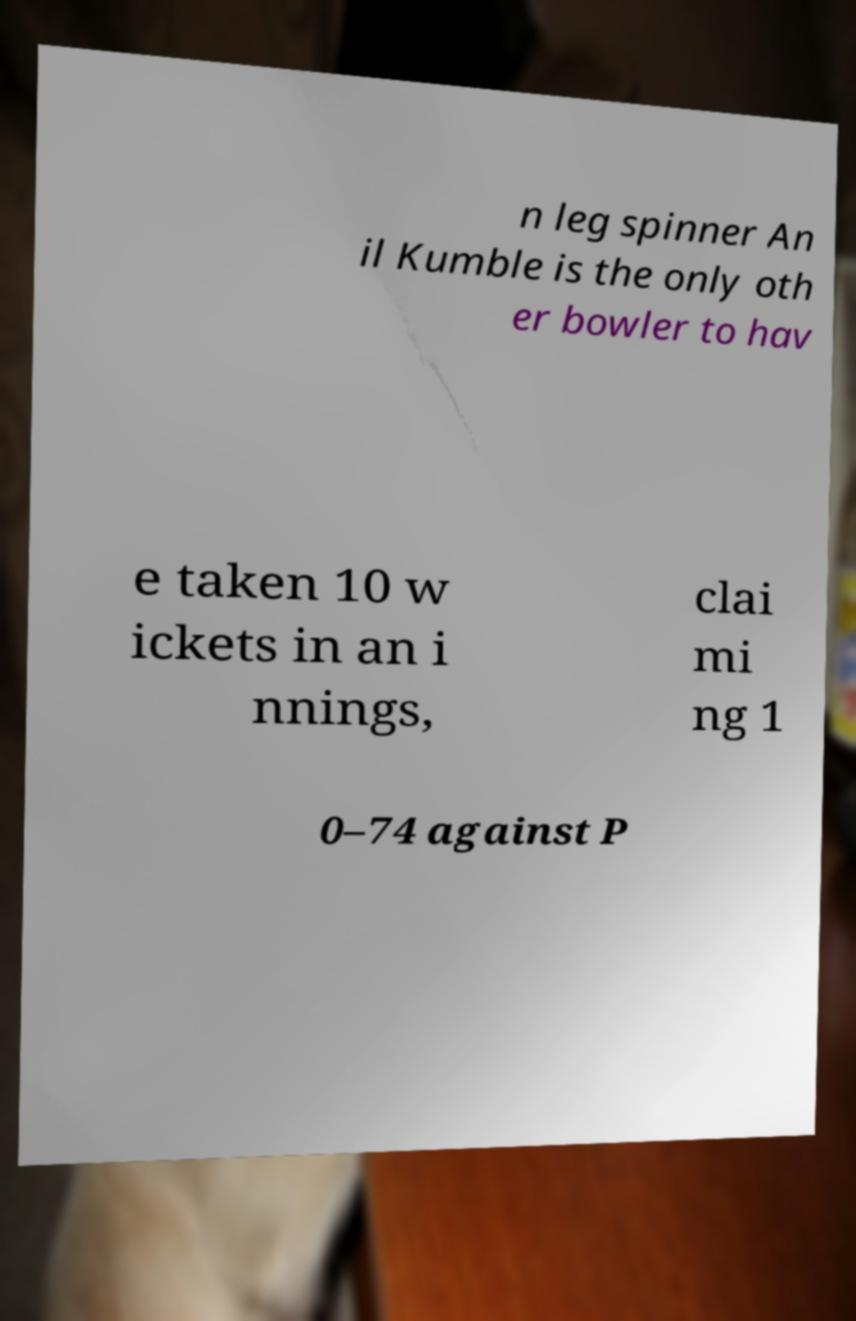Please identify and transcribe the text found in this image. n leg spinner An il Kumble is the only oth er bowler to hav e taken 10 w ickets in an i nnings, clai mi ng 1 0–74 against P 